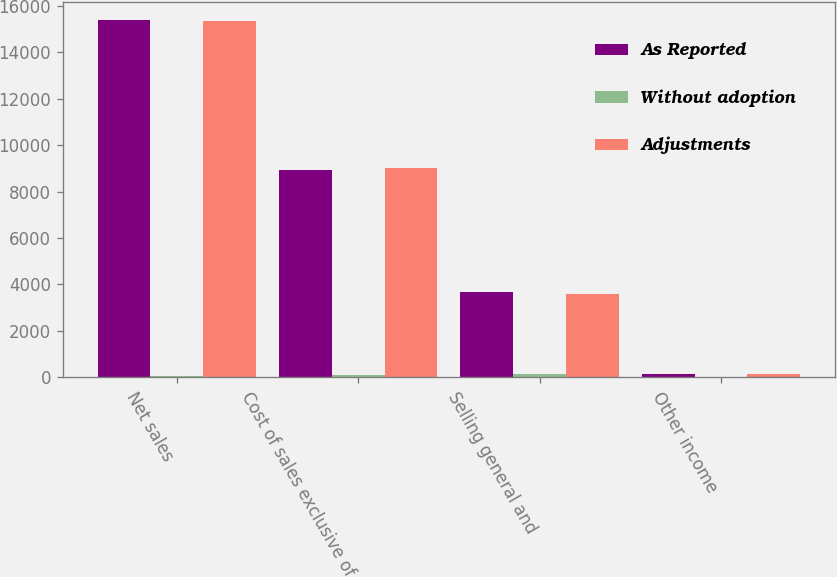Convert chart to OTSL. <chart><loc_0><loc_0><loc_500><loc_500><stacked_bar_chart><ecel><fcel>Net sales<fcel>Cost of sales exclusive of<fcel>Selling general and<fcel>Other income<nl><fcel>As Reported<fcel>15399<fcel>8925<fcel>3682<fcel>122<nl><fcel>Without adoption<fcel>25<fcel>76<fcel>109<fcel>8<nl><fcel>Adjustments<fcel>15374<fcel>9001<fcel>3573<fcel>114<nl></chart> 